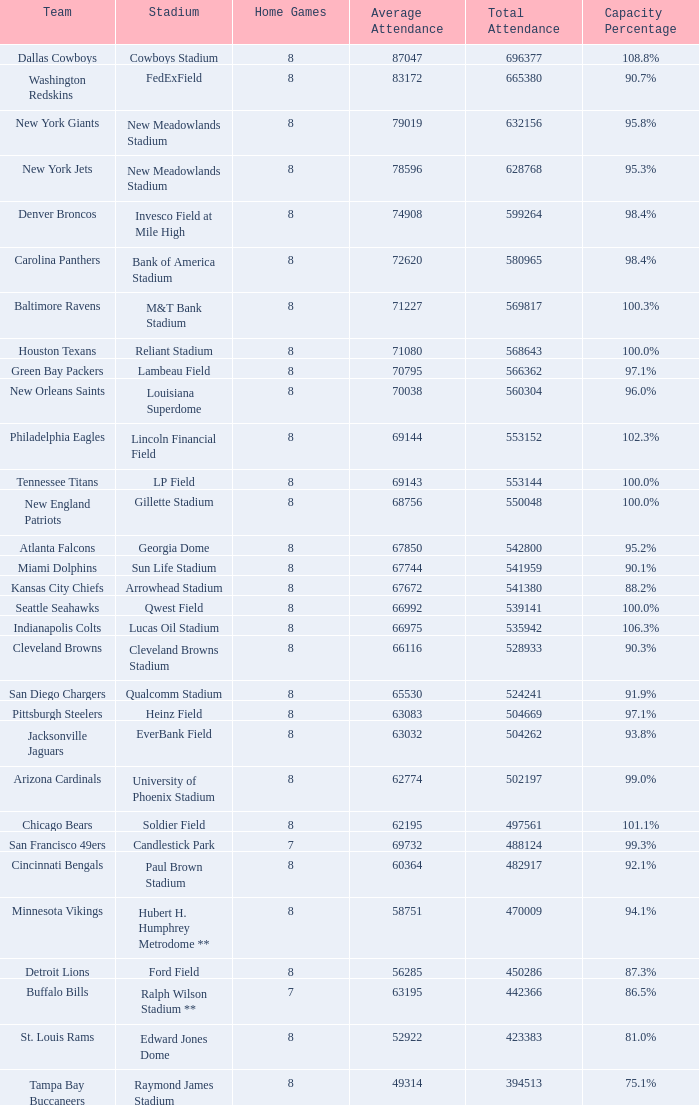What was the mean attendance when the overall attendance reached 541,380? 67672.0. 